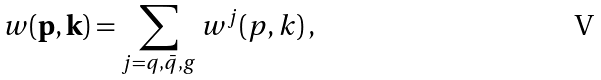<formula> <loc_0><loc_0><loc_500><loc_500>w ( { \mathbf p } , { \mathbf k } ) = \sum _ { j = q , { \bar { q } } , g } w ^ { j } ( p , k ) \, ,</formula> 